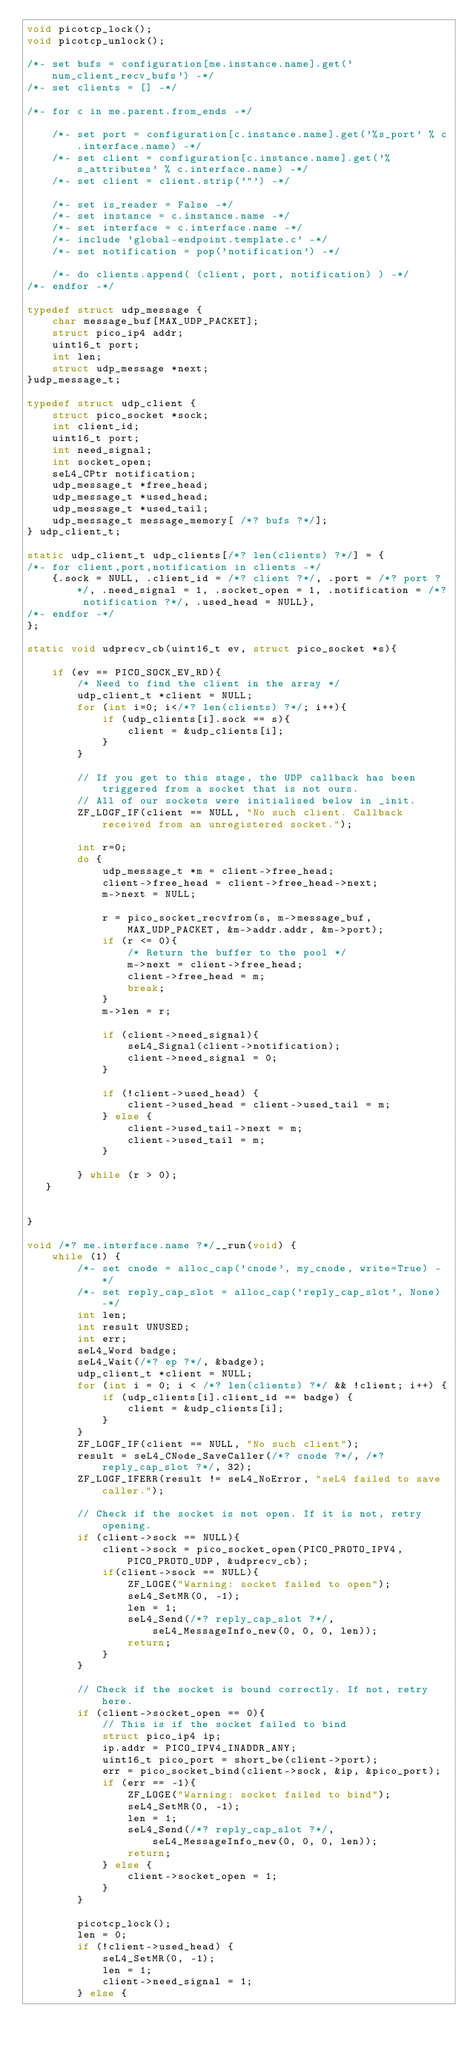<code> <loc_0><loc_0><loc_500><loc_500><_C_>void picotcp_lock();
void picotcp_unlock();

/*- set bufs = configuration[me.instance.name].get('num_client_recv_bufs') -*/
/*- set clients = [] -*/

/*- for c in me.parent.from_ends -*/

    /*- set port = configuration[c.instance.name].get('%s_port' % c.interface.name) -*/
    /*- set client = configuration[c.instance.name].get('%s_attributes' % c.interface.name) -*/
    /*- set client = client.strip('"') -*/

    /*- set is_reader = False -*/
    /*- set instance = c.instance.name -*/
    /*- set interface = c.interface.name -*/
    /*- include 'global-endpoint.template.c' -*/
    /*- set notification = pop('notification') -*/

    /*- do clients.append( (client, port, notification) ) -*/
/*- endfor -*/

typedef struct udp_message {
    char message_buf[MAX_UDP_PACKET];
    struct pico_ip4 addr;
    uint16_t port;
    int len;
    struct udp_message *next;
}udp_message_t;

typedef struct udp_client {
    struct pico_socket *sock;
    int client_id;
    uint16_t port;
    int need_signal;
    int socket_open;
    seL4_CPtr notification;
    udp_message_t *free_head;
    udp_message_t *used_head;
    udp_message_t *used_tail;
    udp_message_t message_memory[ /*? bufs ?*/];
} udp_client_t;

static udp_client_t udp_clients[/*? len(clients) ?*/] = {
/*- for client,port,notification in clients -*/
    {.sock = NULL, .client_id = /*? client ?*/, .port = /*? port ?*/, .need_signal = 1, .socket_open = 1, .notification = /*? notification ?*/, .used_head = NULL},
/*- endfor -*/
};

static void udprecv_cb(uint16_t ev, struct pico_socket *s){

    if (ev == PICO_SOCK_EV_RD){
        /* Need to find the client in the array */
        udp_client_t *client = NULL; 
        for (int i=0; i</*? len(clients) ?*/; i++){
            if (udp_clients[i].sock == s){
                client = &udp_clients[i];
            }
        }
        
        // If you get to this stage, the UDP callback has been triggered from a socket that is not ours. 
        // All of our sockets were initialised below in _init. 
        ZF_LOGF_IF(client == NULL, "No such client. Callback received from an unregistered socket.");
            
        int r=0;
        do {
            udp_message_t *m = client->free_head; 
            client->free_head = client->free_head->next; 
            m->next = NULL;

            r = pico_socket_recvfrom(s, m->message_buf, MAX_UDP_PACKET, &m->addr.addr, &m->port);
            if (r <= 0){
                /* Return the buffer to the pool */
                m->next = client->free_head;
                client->free_head = m;
                break; 
            }
            m->len = r;

            if (client->need_signal){
                seL4_Signal(client->notification);
                client->need_signal = 0;
            }

            if (!client->used_head) {
                client->used_head = client->used_tail = m;
            } else {
                client->used_tail->next = m;
                client->used_tail = m;
            }

        } while (r > 0);
   }


}

void /*? me.interface.name ?*/__run(void) {
    while (1) {
        /*- set cnode = alloc_cap('cnode', my_cnode, write=True) -*/
        /*- set reply_cap_slot = alloc_cap('reply_cap_slot', None) -*/
        int len;
        int result UNUSED;
        int err;
        seL4_Word badge;
        seL4_Wait(/*? ep ?*/, &badge);
        udp_client_t *client = NULL;
        for (int i = 0; i < /*? len(clients) ?*/ && !client; i++) {
            if (udp_clients[i].client_id == badge) {
                client = &udp_clients[i];
            }
        }
        ZF_LOGF_IF(client == NULL, "No such client");
        result = seL4_CNode_SaveCaller(/*? cnode ?*/, /*? reply_cap_slot ?*/, 32);
        ZF_LOGF_IFERR(result != seL4_NoError, "seL4 failed to save caller.");
        
        // Check if the socket is not open. If it is not, retry opening.
        if (client->sock == NULL){
            client->sock = pico_socket_open(PICO_PROTO_IPV4, PICO_PROTO_UDP, &udprecv_cb);
            if(client->sock == NULL){
                ZF_LOGE("Warning: socket failed to open");
                seL4_SetMR(0, -1);
                len = 1;
                seL4_Send(/*? reply_cap_slot ?*/, seL4_MessageInfo_new(0, 0, 0, len));
                return;
            }
        }
        
        // Check if the socket is bound correctly. If not, retry here. 
        if (client->socket_open == 0){
            // This is if the socket failed to bind
            struct pico_ip4 ip; 
            ip.addr = PICO_IPV4_INADDR_ANY; 
            uint16_t pico_port = short_be(client->port);
            err = pico_socket_bind(client->sock, &ip, &pico_port);
            if (err == -1){
                ZF_LOGE("Warning: socket failed to bind");
                seL4_SetMR(0, -1);
                len = 1;
                seL4_Send(/*? reply_cap_slot ?*/, seL4_MessageInfo_new(0, 0, 0, len));
                return;
            } else {
                client->socket_open = 1;
            }
        }

        picotcp_lock();
        len = 0;
        if (!client->used_head) {
            seL4_SetMR(0, -1);
            len = 1;
            client->need_signal = 1;
        } else {</code> 